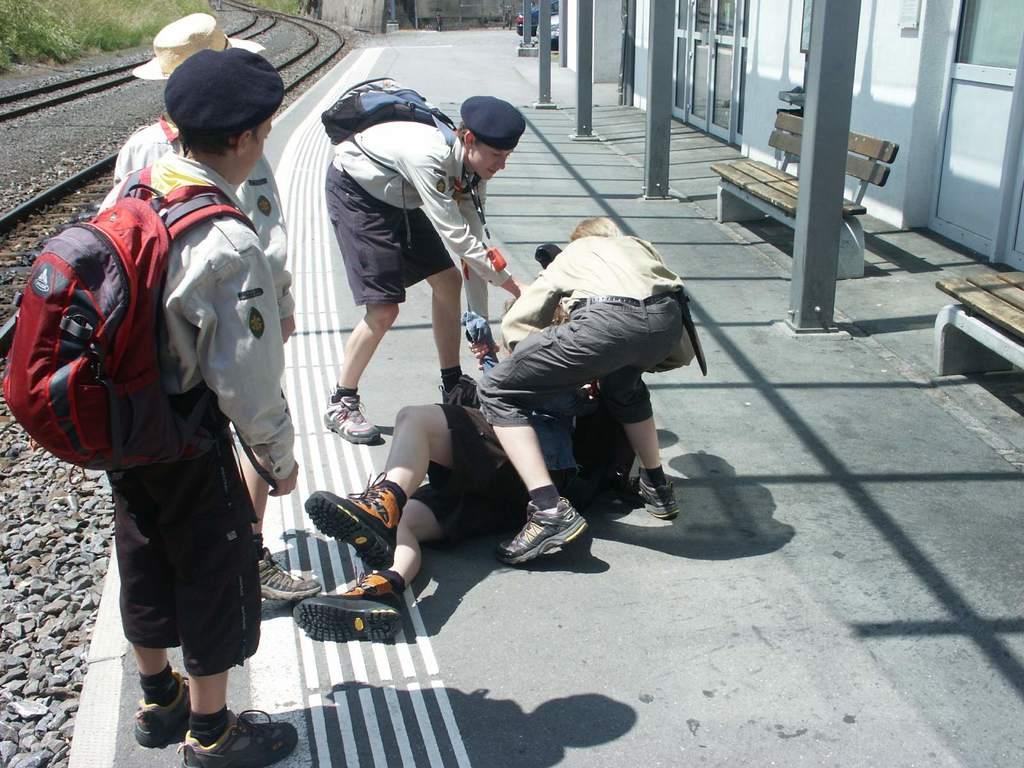Can you describe this image briefly? In this picture we can see there are four persons standing and a person is lying on the platform. On the right side of the people there are pillars, benches and it looks like a station. On the left side of the people there are stones, railway tracks and plants. At the top of the image, there is a vehicle. 